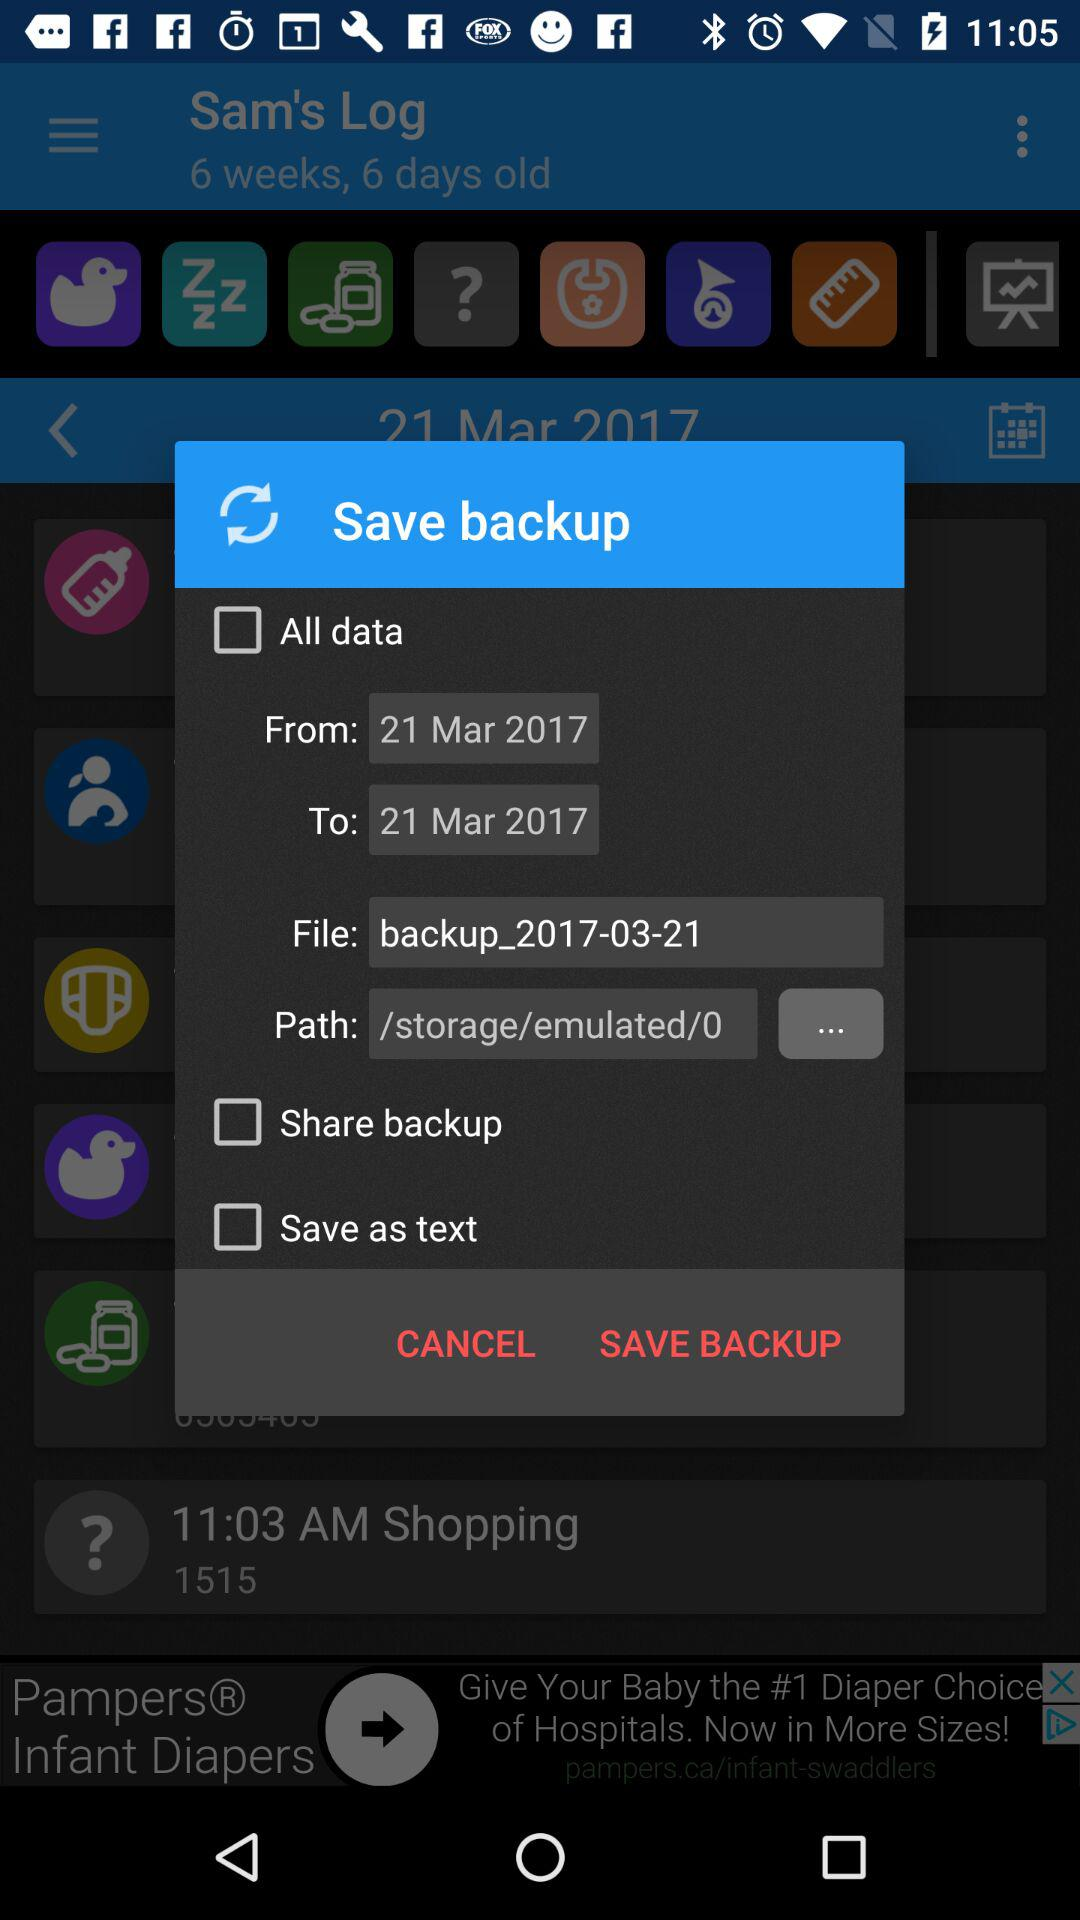What is the file name? The file name is "backup_2017-03-21". 